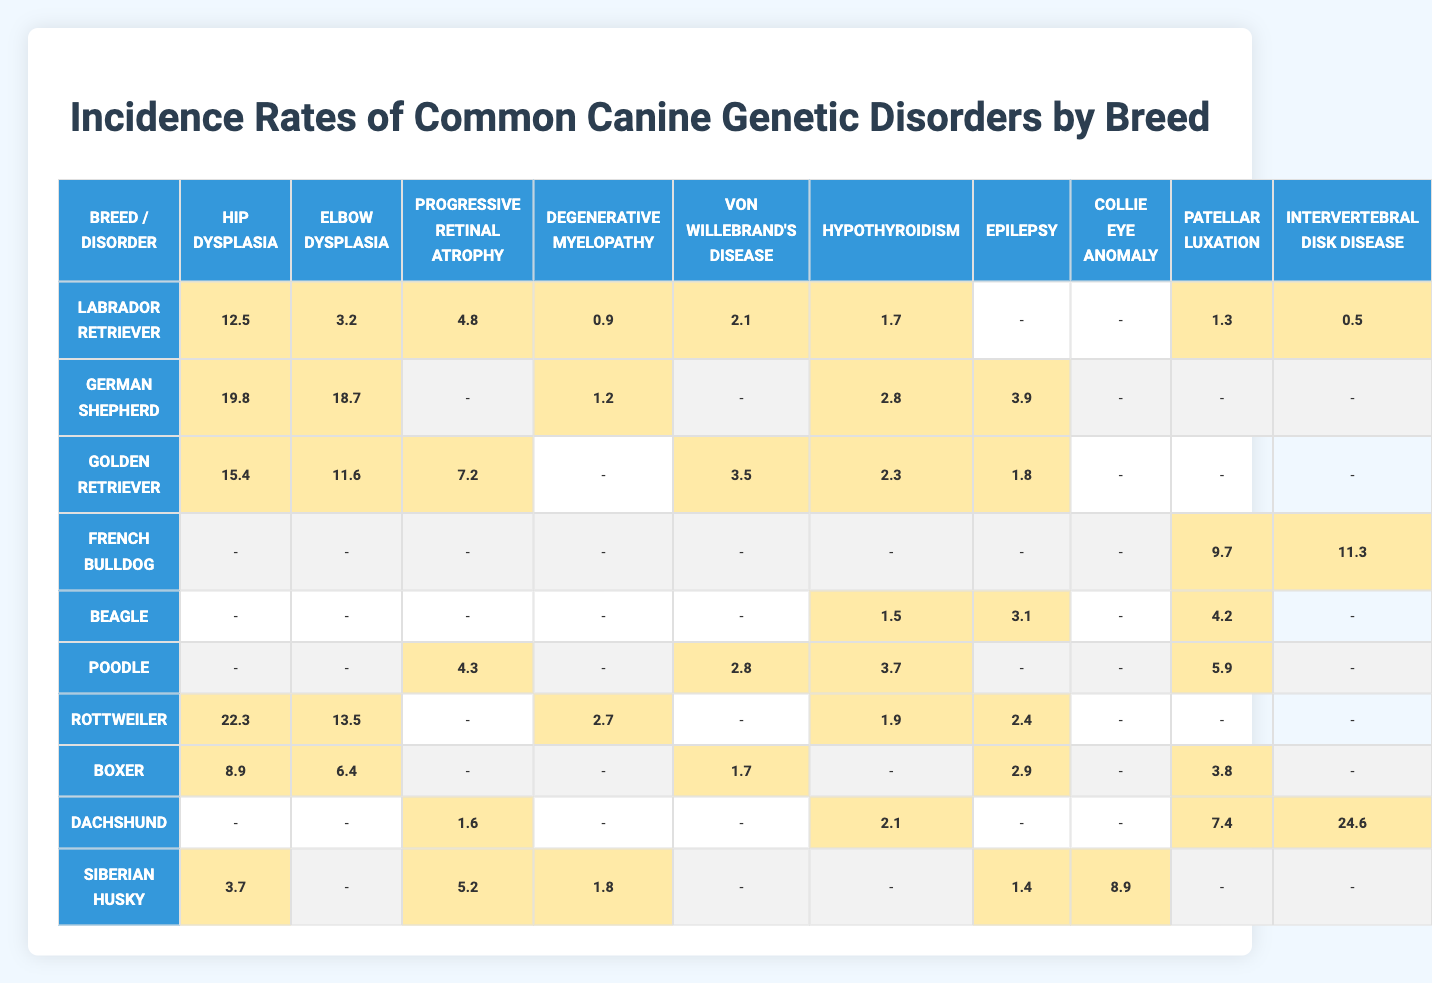What is the incidence rate of Hip Dysplasia in Labrador Retrievers? The table shows that the incidence rate of Hip Dysplasia for Labrador Retrievers is 12.5%.
Answer: 12.5% Which breed has the highest incidence rate of Elbow Dysplasia? The table indicates that the highest incidence rate of Elbow Dysplasia is in German Shepherds at 18.7%.
Answer: German Shepherd What is the total incidence rate of Progressive Retinal Atrophy across all breeds? By summing the rates for Progressive Retinal Atrophy from all breeds, we get (4.8 + 0 + 7.2 + 0 + 0 + 4.3 + 0 + 0 + 1.6 + 5.2) = 23.1%.
Answer: 23.1% Which breed has the lowest incidence rate of Von Willebrand's Disease? Looking at the table, Beagles have an incidence rate of 0% for Von Willebrand's Disease, the lowest among all breeds.
Answer: Beagle What is the average incidence rate of Hypothyroidism for all listed breeds? Adding the incidence rates of Hypothyroidism: (1.7 + 2.8 + 2.3 + 0 + 0 + 3.7 + 1.9 + 0 + 2.1 + 0) = 12.5%. Dividing by the number of breeds (10), we find the average is 12.5% / 10 = 1.25%.
Answer: 1.25% Is the incidence of Degenerative Myelopathy higher in Poodles than in French Bulldogs? The incidence of Degenerative Myelopathy for Poodles is 0% and for French Bulldogs is 0%, so they are equal.
Answer: No Which two breeds have an incidence rate of 0% for Intervertebral Disk Disease? The table shows that both Labrador Retrievers and German Shepherds have an incidence rate of 0% for Intervertebral Disk Disease.
Answer: Labrador Retriever and German Shepherd Which breed shows the highest overall incidence of genetic disorders when looking at the total incidence rates? By summing up all genetic disorder incidence rates for each breed, Rottweilers have the highest total at 40.8% (22.3 + 13.5 + 0 + 2.7 + 0 + 1.9 + 2.4 + 0 + 0 + 0).
Answer: Rottweiler Are there any breeds that show an incidence rate greater than 10% for Patellar Luxation? Upon reviewing the table, only Golden Retrievers and Dachshunds exceed a 10% incidence rate for Patellar Luxation (3.5% and 4.2% respectively, but they are less than 10%).
Answer: No What is the incidence rate difference for Epilepsy between Poodles and Labradors? The incidence rate for Epilepsy in Poodles is 0% and in Labradors is 0%. Therefore, the difference is 0% - 0% = 0%.
Answer: 0% What percentage of German Shepherds are diagnosed with any form of genetic disorder listed in the table? By summing the incidence rates for all genetic disorders in German Shepherds, we find (19.8 + 18.7 + 0 + 1.2 + 0 + 2.8 + 3.9 + 0 + 0 + 0) = 46.6%.
Answer: 46.6% 